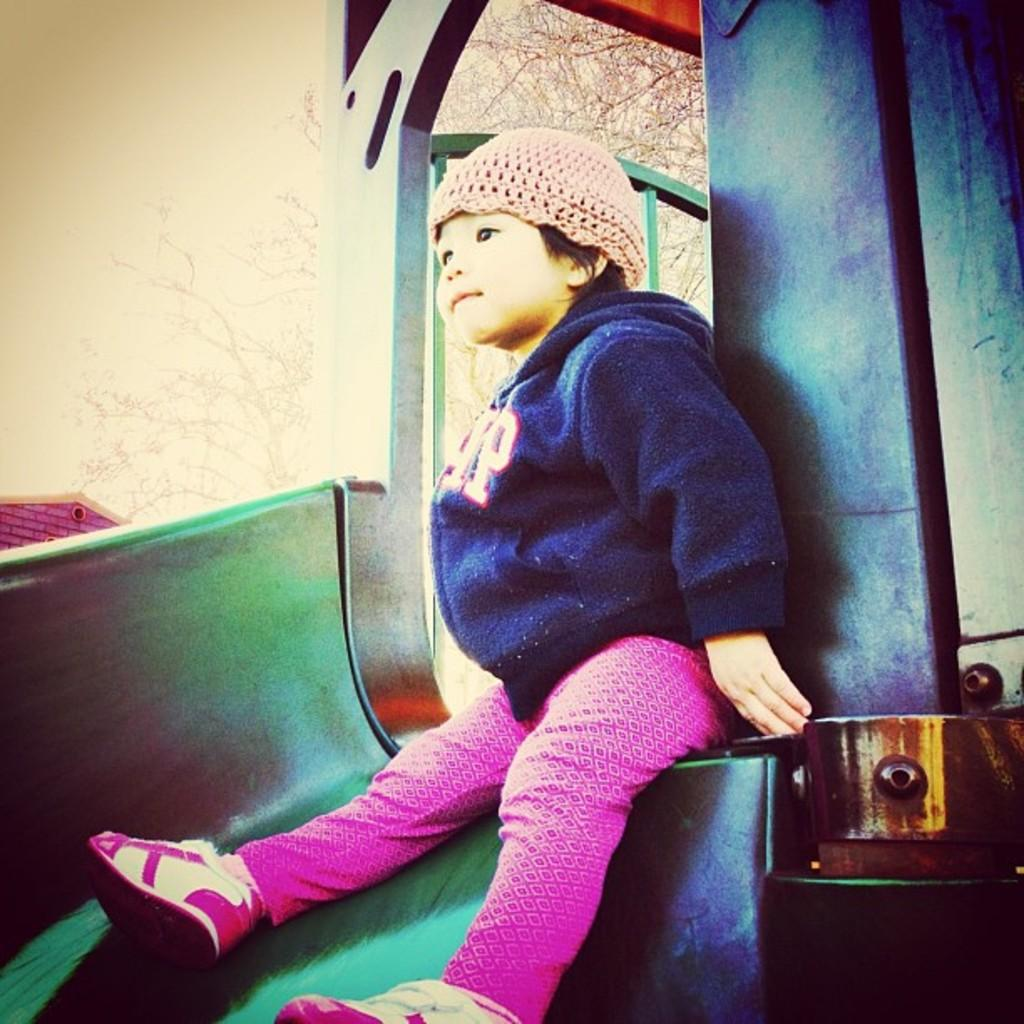What is the main subject of the image? The main subject of the image is a baby. What is the baby wearing in the image? The baby is wearing a sweater and pink-colored trousers. What type of fiction is the baby reading in the image? There is no book or any form of reading material present in the image, so it cannot be determined if the baby is reading fiction or any other type of content. 